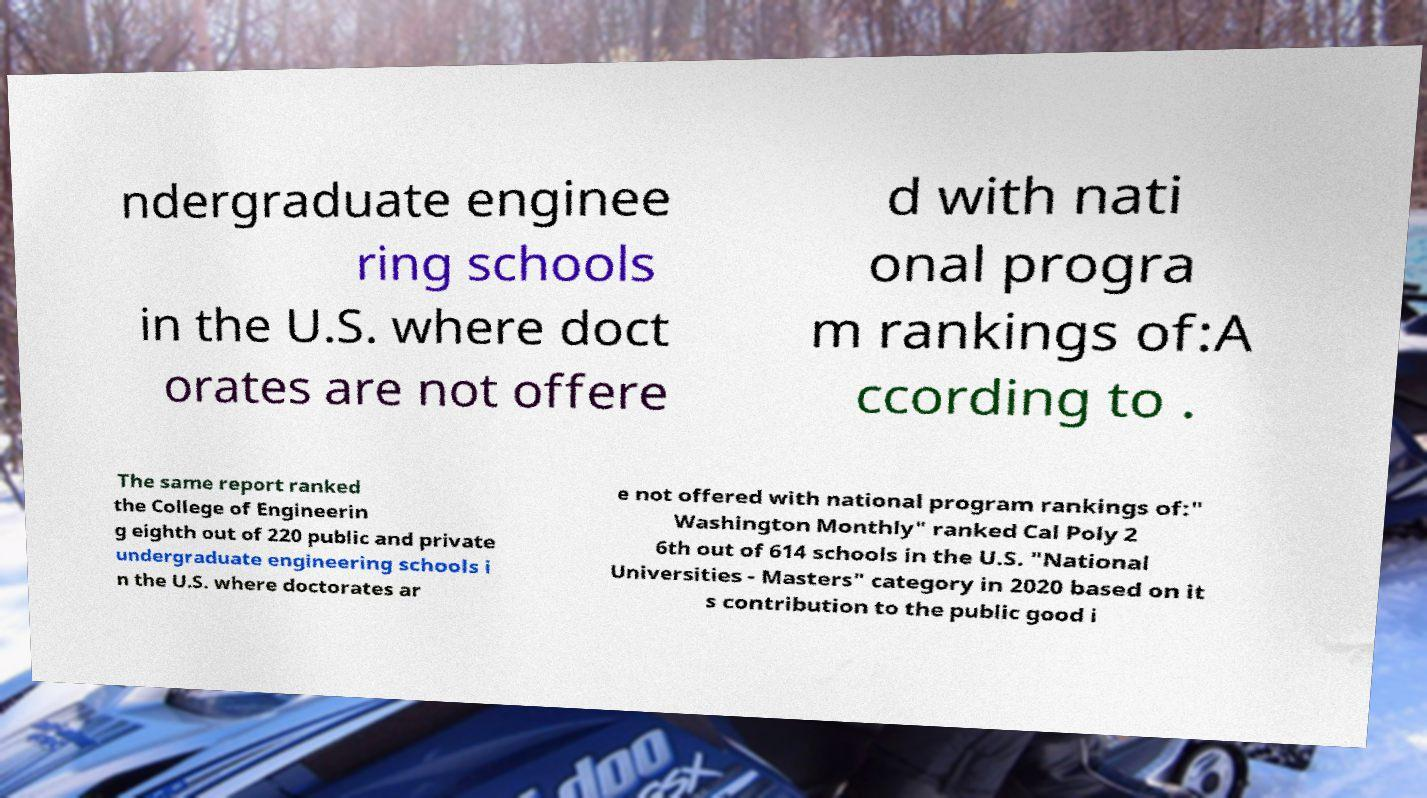For documentation purposes, I need the text within this image transcribed. Could you provide that? ndergraduate enginee ring schools in the U.S. where doct orates are not offere d with nati onal progra m rankings of:A ccording to . The same report ranked the College of Engineerin g eighth out of 220 public and private undergraduate engineering schools i n the U.S. where doctorates ar e not offered with national program rankings of:" Washington Monthly" ranked Cal Poly 2 6th out of 614 schools in the U.S. "National Universities - Masters" category in 2020 based on it s contribution to the public good i 